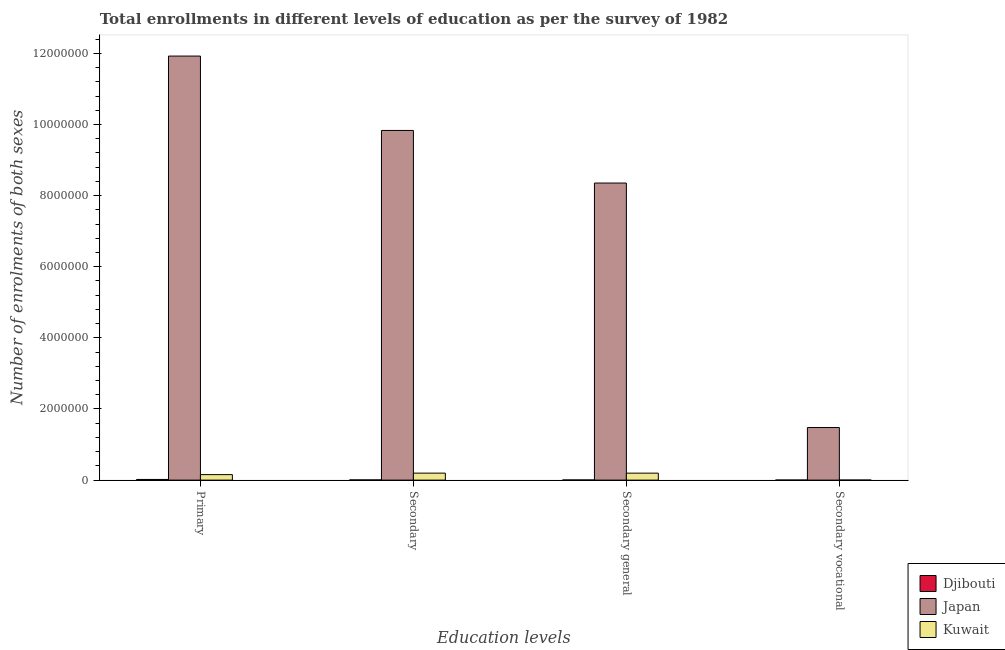How many different coloured bars are there?
Your answer should be very brief. 3. How many groups of bars are there?
Ensure brevity in your answer.  4. Are the number of bars per tick equal to the number of legend labels?
Offer a very short reply. Yes. Are the number of bars on each tick of the X-axis equal?
Offer a very short reply. Yes. What is the label of the 4th group of bars from the left?
Your answer should be compact. Secondary vocational. What is the number of enrolments in secondary vocational education in Japan?
Your response must be concise. 1.48e+06. Across all countries, what is the maximum number of enrolments in primary education?
Your response must be concise. 1.19e+07. Across all countries, what is the minimum number of enrolments in secondary vocational education?
Give a very brief answer. 672. In which country was the number of enrolments in primary education minimum?
Offer a terse response. Djibouti. What is the total number of enrolments in secondary vocational education in the graph?
Give a very brief answer. 1.48e+06. What is the difference between the number of enrolments in secondary general education in Kuwait and that in Japan?
Keep it short and to the point. -8.16e+06. What is the difference between the number of enrolments in secondary general education in Kuwait and the number of enrolments in secondary vocational education in Djibouti?
Provide a short and direct response. 1.94e+05. What is the average number of enrolments in secondary general education per country?
Offer a terse response. 2.85e+06. What is the difference between the number of enrolments in secondary general education and number of enrolments in secondary vocational education in Japan?
Keep it short and to the point. 6.88e+06. What is the ratio of the number of enrolments in secondary general education in Japan to that in Djibouti?
Offer a very short reply. 2049.62. Is the number of enrolments in secondary general education in Kuwait less than that in Djibouti?
Give a very brief answer. No. What is the difference between the highest and the second highest number of enrolments in secondary general education?
Offer a very short reply. 8.16e+06. What is the difference between the highest and the lowest number of enrolments in secondary vocational education?
Keep it short and to the point. 1.48e+06. Is the sum of the number of enrolments in secondary vocational education in Japan and Djibouti greater than the maximum number of enrolments in secondary general education across all countries?
Offer a very short reply. No. What does the 2nd bar from the left in Secondary general represents?
Offer a very short reply. Japan. What does the 3rd bar from the right in Primary represents?
Provide a succinct answer. Djibouti. Are all the bars in the graph horizontal?
Offer a terse response. No. What is the difference between two consecutive major ticks on the Y-axis?
Keep it short and to the point. 2.00e+06. Does the graph contain grids?
Your response must be concise. No. How many legend labels are there?
Offer a very short reply. 3. What is the title of the graph?
Your answer should be compact. Total enrollments in different levels of education as per the survey of 1982. What is the label or title of the X-axis?
Make the answer very short. Education levels. What is the label or title of the Y-axis?
Make the answer very short. Number of enrolments of both sexes. What is the Number of enrolments of both sexes in Djibouti in Primary?
Provide a short and direct response. 1.89e+04. What is the Number of enrolments of both sexes in Japan in Primary?
Give a very brief answer. 1.19e+07. What is the Number of enrolments of both sexes of Kuwait in Primary?
Provide a short and direct response. 1.55e+05. What is the Number of enrolments of both sexes in Djibouti in Secondary?
Make the answer very short. 5543. What is the Number of enrolments of both sexes of Japan in Secondary?
Make the answer very short. 9.83e+06. What is the Number of enrolments of both sexes in Kuwait in Secondary?
Offer a terse response. 1.96e+05. What is the Number of enrolments of both sexes of Djibouti in Secondary general?
Your answer should be very brief. 4076. What is the Number of enrolments of both sexes of Japan in Secondary general?
Ensure brevity in your answer.  8.35e+06. What is the Number of enrolments of both sexes in Kuwait in Secondary general?
Your answer should be compact. 1.96e+05. What is the Number of enrolments of both sexes in Djibouti in Secondary vocational?
Your answer should be compact. 1467. What is the Number of enrolments of both sexes in Japan in Secondary vocational?
Your response must be concise. 1.48e+06. What is the Number of enrolments of both sexes in Kuwait in Secondary vocational?
Keep it short and to the point. 672. Across all Education levels, what is the maximum Number of enrolments of both sexes in Djibouti?
Keep it short and to the point. 1.89e+04. Across all Education levels, what is the maximum Number of enrolments of both sexes in Japan?
Ensure brevity in your answer.  1.19e+07. Across all Education levels, what is the maximum Number of enrolments of both sexes of Kuwait?
Ensure brevity in your answer.  1.96e+05. Across all Education levels, what is the minimum Number of enrolments of both sexes of Djibouti?
Offer a terse response. 1467. Across all Education levels, what is the minimum Number of enrolments of both sexes of Japan?
Offer a very short reply. 1.48e+06. Across all Education levels, what is the minimum Number of enrolments of both sexes of Kuwait?
Give a very brief answer. 672. What is the total Number of enrolments of both sexes of Djibouti in the graph?
Your answer should be compact. 3.00e+04. What is the total Number of enrolments of both sexes of Japan in the graph?
Ensure brevity in your answer.  3.16e+07. What is the total Number of enrolments of both sexes of Kuwait in the graph?
Your answer should be compact. 5.48e+05. What is the difference between the Number of enrolments of both sexes in Djibouti in Primary and that in Secondary?
Offer a terse response. 1.34e+04. What is the difference between the Number of enrolments of both sexes in Japan in Primary and that in Secondary?
Ensure brevity in your answer.  2.09e+06. What is the difference between the Number of enrolments of both sexes of Kuwait in Primary and that in Secondary?
Give a very brief answer. -4.16e+04. What is the difference between the Number of enrolments of both sexes of Djibouti in Primary and that in Secondary general?
Provide a short and direct response. 1.48e+04. What is the difference between the Number of enrolments of both sexes of Japan in Primary and that in Secondary general?
Your response must be concise. 3.57e+06. What is the difference between the Number of enrolments of both sexes of Kuwait in Primary and that in Secondary general?
Keep it short and to the point. -4.10e+04. What is the difference between the Number of enrolments of both sexes in Djibouti in Primary and that in Secondary vocational?
Ensure brevity in your answer.  1.74e+04. What is the difference between the Number of enrolments of both sexes in Japan in Primary and that in Secondary vocational?
Give a very brief answer. 1.04e+07. What is the difference between the Number of enrolments of both sexes of Kuwait in Primary and that in Secondary vocational?
Provide a short and direct response. 1.54e+05. What is the difference between the Number of enrolments of both sexes in Djibouti in Secondary and that in Secondary general?
Your answer should be compact. 1467. What is the difference between the Number of enrolments of both sexes in Japan in Secondary and that in Secondary general?
Give a very brief answer. 1.48e+06. What is the difference between the Number of enrolments of both sexes in Kuwait in Secondary and that in Secondary general?
Your answer should be compact. 672. What is the difference between the Number of enrolments of both sexes of Djibouti in Secondary and that in Secondary vocational?
Make the answer very short. 4076. What is the difference between the Number of enrolments of both sexes of Japan in Secondary and that in Secondary vocational?
Your answer should be very brief. 8.35e+06. What is the difference between the Number of enrolments of both sexes of Kuwait in Secondary and that in Secondary vocational?
Make the answer very short. 1.96e+05. What is the difference between the Number of enrolments of both sexes in Djibouti in Secondary general and that in Secondary vocational?
Give a very brief answer. 2609. What is the difference between the Number of enrolments of both sexes of Japan in Secondary general and that in Secondary vocational?
Your response must be concise. 6.88e+06. What is the difference between the Number of enrolments of both sexes in Kuwait in Secondary general and that in Secondary vocational?
Offer a terse response. 1.95e+05. What is the difference between the Number of enrolments of both sexes in Djibouti in Primary and the Number of enrolments of both sexes in Japan in Secondary?
Offer a very short reply. -9.81e+06. What is the difference between the Number of enrolments of both sexes in Djibouti in Primary and the Number of enrolments of both sexes in Kuwait in Secondary?
Offer a very short reply. -1.78e+05. What is the difference between the Number of enrolments of both sexes in Japan in Primary and the Number of enrolments of both sexes in Kuwait in Secondary?
Your answer should be very brief. 1.17e+07. What is the difference between the Number of enrolments of both sexes of Djibouti in Primary and the Number of enrolments of both sexes of Japan in Secondary general?
Provide a succinct answer. -8.34e+06. What is the difference between the Number of enrolments of both sexes of Djibouti in Primary and the Number of enrolments of both sexes of Kuwait in Secondary general?
Offer a very short reply. -1.77e+05. What is the difference between the Number of enrolments of both sexes in Japan in Primary and the Number of enrolments of both sexes in Kuwait in Secondary general?
Your answer should be compact. 1.17e+07. What is the difference between the Number of enrolments of both sexes of Djibouti in Primary and the Number of enrolments of both sexes of Japan in Secondary vocational?
Give a very brief answer. -1.46e+06. What is the difference between the Number of enrolments of both sexes in Djibouti in Primary and the Number of enrolments of both sexes in Kuwait in Secondary vocational?
Your response must be concise. 1.82e+04. What is the difference between the Number of enrolments of both sexes of Japan in Primary and the Number of enrolments of both sexes of Kuwait in Secondary vocational?
Provide a short and direct response. 1.19e+07. What is the difference between the Number of enrolments of both sexes of Djibouti in Secondary and the Number of enrolments of both sexes of Japan in Secondary general?
Provide a short and direct response. -8.35e+06. What is the difference between the Number of enrolments of both sexes of Djibouti in Secondary and the Number of enrolments of both sexes of Kuwait in Secondary general?
Give a very brief answer. -1.90e+05. What is the difference between the Number of enrolments of both sexes of Japan in Secondary and the Number of enrolments of both sexes of Kuwait in Secondary general?
Offer a very short reply. 9.64e+06. What is the difference between the Number of enrolments of both sexes of Djibouti in Secondary and the Number of enrolments of both sexes of Japan in Secondary vocational?
Provide a short and direct response. -1.47e+06. What is the difference between the Number of enrolments of both sexes in Djibouti in Secondary and the Number of enrolments of both sexes in Kuwait in Secondary vocational?
Offer a very short reply. 4871. What is the difference between the Number of enrolments of both sexes of Japan in Secondary and the Number of enrolments of both sexes of Kuwait in Secondary vocational?
Your response must be concise. 9.83e+06. What is the difference between the Number of enrolments of both sexes in Djibouti in Secondary general and the Number of enrolments of both sexes in Japan in Secondary vocational?
Your response must be concise. -1.47e+06. What is the difference between the Number of enrolments of both sexes in Djibouti in Secondary general and the Number of enrolments of both sexes in Kuwait in Secondary vocational?
Keep it short and to the point. 3404. What is the difference between the Number of enrolments of both sexes of Japan in Secondary general and the Number of enrolments of both sexes of Kuwait in Secondary vocational?
Your answer should be very brief. 8.35e+06. What is the average Number of enrolments of both sexes of Djibouti per Education levels?
Your answer should be compact. 7495.5. What is the average Number of enrolments of both sexes of Japan per Education levels?
Your answer should be compact. 7.90e+06. What is the average Number of enrolments of both sexes in Kuwait per Education levels?
Offer a very short reply. 1.37e+05. What is the difference between the Number of enrolments of both sexes of Djibouti and Number of enrolments of both sexes of Japan in Primary?
Ensure brevity in your answer.  -1.19e+07. What is the difference between the Number of enrolments of both sexes of Djibouti and Number of enrolments of both sexes of Kuwait in Primary?
Keep it short and to the point. -1.36e+05. What is the difference between the Number of enrolments of both sexes in Japan and Number of enrolments of both sexes in Kuwait in Primary?
Offer a very short reply. 1.18e+07. What is the difference between the Number of enrolments of both sexes in Djibouti and Number of enrolments of both sexes in Japan in Secondary?
Your response must be concise. -9.83e+06. What is the difference between the Number of enrolments of both sexes of Djibouti and Number of enrolments of both sexes of Kuwait in Secondary?
Your response must be concise. -1.91e+05. What is the difference between the Number of enrolments of both sexes in Japan and Number of enrolments of both sexes in Kuwait in Secondary?
Keep it short and to the point. 9.64e+06. What is the difference between the Number of enrolments of both sexes of Djibouti and Number of enrolments of both sexes of Japan in Secondary general?
Your answer should be compact. -8.35e+06. What is the difference between the Number of enrolments of both sexes in Djibouti and Number of enrolments of both sexes in Kuwait in Secondary general?
Your response must be concise. -1.92e+05. What is the difference between the Number of enrolments of both sexes in Japan and Number of enrolments of both sexes in Kuwait in Secondary general?
Provide a short and direct response. 8.16e+06. What is the difference between the Number of enrolments of both sexes in Djibouti and Number of enrolments of both sexes in Japan in Secondary vocational?
Provide a short and direct response. -1.48e+06. What is the difference between the Number of enrolments of both sexes of Djibouti and Number of enrolments of both sexes of Kuwait in Secondary vocational?
Provide a short and direct response. 795. What is the difference between the Number of enrolments of both sexes of Japan and Number of enrolments of both sexes of Kuwait in Secondary vocational?
Provide a succinct answer. 1.48e+06. What is the ratio of the Number of enrolments of both sexes in Djibouti in Primary to that in Secondary?
Make the answer very short. 3.41. What is the ratio of the Number of enrolments of both sexes of Japan in Primary to that in Secondary?
Make the answer very short. 1.21. What is the ratio of the Number of enrolments of both sexes of Kuwait in Primary to that in Secondary?
Offer a terse response. 0.79. What is the ratio of the Number of enrolments of both sexes of Djibouti in Primary to that in Secondary general?
Provide a short and direct response. 4.64. What is the ratio of the Number of enrolments of both sexes in Japan in Primary to that in Secondary general?
Provide a short and direct response. 1.43. What is the ratio of the Number of enrolments of both sexes of Kuwait in Primary to that in Secondary general?
Offer a very short reply. 0.79. What is the ratio of the Number of enrolments of both sexes in Djibouti in Primary to that in Secondary vocational?
Keep it short and to the point. 12.88. What is the ratio of the Number of enrolments of both sexes of Japan in Primary to that in Secondary vocational?
Provide a short and direct response. 8.06. What is the ratio of the Number of enrolments of both sexes in Kuwait in Primary to that in Secondary vocational?
Offer a very short reply. 230.32. What is the ratio of the Number of enrolments of both sexes in Djibouti in Secondary to that in Secondary general?
Keep it short and to the point. 1.36. What is the ratio of the Number of enrolments of both sexes in Japan in Secondary to that in Secondary general?
Offer a very short reply. 1.18. What is the ratio of the Number of enrolments of both sexes in Kuwait in Secondary to that in Secondary general?
Make the answer very short. 1. What is the ratio of the Number of enrolments of both sexes in Djibouti in Secondary to that in Secondary vocational?
Make the answer very short. 3.78. What is the ratio of the Number of enrolments of both sexes in Japan in Secondary to that in Secondary vocational?
Your answer should be very brief. 6.65. What is the ratio of the Number of enrolments of both sexes in Kuwait in Secondary to that in Secondary vocational?
Provide a short and direct response. 292.28. What is the ratio of the Number of enrolments of both sexes in Djibouti in Secondary general to that in Secondary vocational?
Offer a very short reply. 2.78. What is the ratio of the Number of enrolments of both sexes in Japan in Secondary general to that in Secondary vocational?
Provide a short and direct response. 5.65. What is the ratio of the Number of enrolments of both sexes in Kuwait in Secondary general to that in Secondary vocational?
Provide a short and direct response. 291.28. What is the difference between the highest and the second highest Number of enrolments of both sexes in Djibouti?
Offer a very short reply. 1.34e+04. What is the difference between the highest and the second highest Number of enrolments of both sexes in Japan?
Provide a succinct answer. 2.09e+06. What is the difference between the highest and the second highest Number of enrolments of both sexes in Kuwait?
Provide a short and direct response. 672. What is the difference between the highest and the lowest Number of enrolments of both sexes of Djibouti?
Keep it short and to the point. 1.74e+04. What is the difference between the highest and the lowest Number of enrolments of both sexes of Japan?
Your answer should be compact. 1.04e+07. What is the difference between the highest and the lowest Number of enrolments of both sexes in Kuwait?
Provide a short and direct response. 1.96e+05. 